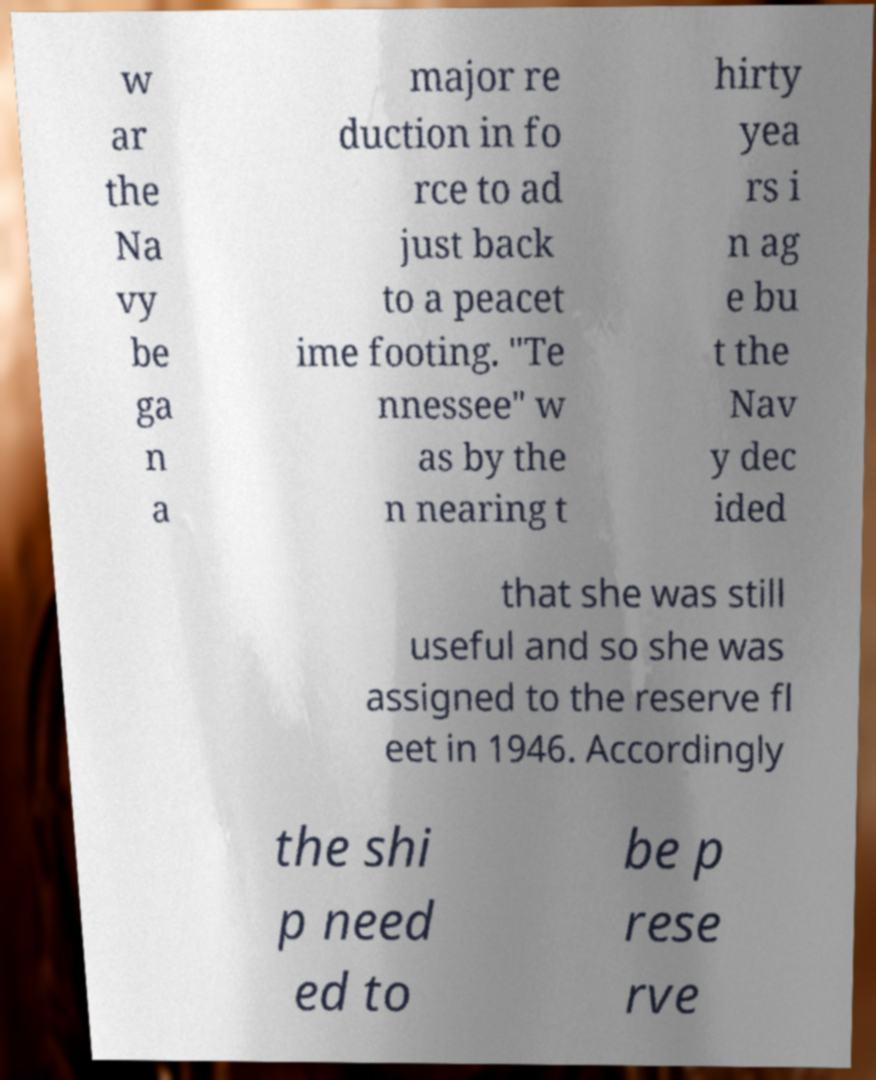For documentation purposes, I need the text within this image transcribed. Could you provide that? w ar the Na vy be ga n a major re duction in fo rce to ad just back to a peacet ime footing. "Te nnessee" w as by the n nearing t hirty yea rs i n ag e bu t the Nav y dec ided that she was still useful and so she was assigned to the reserve fl eet in 1946. Accordingly the shi p need ed to be p rese rve 